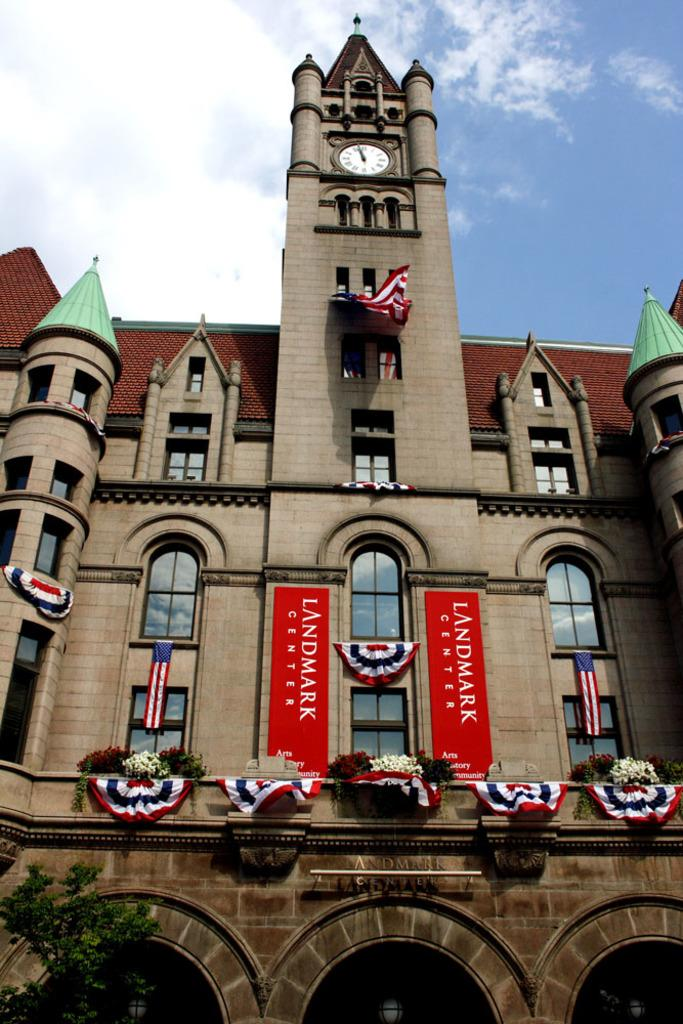What type of structure is the main subject of the image? There is a castle in the image. What decorative elements are present on the castle? Flags are hanging on the castle. What type of natural elements can be seen in the image? There are flowers and a tree in the image. What functional object is present in the image? There is a clock in the image. How would you describe the weather based on the image? The sky is cloudy in the image. What type of canvas is used to create the castle in the image? The image is not a painting or artwork, so there is no canvas used to create the castle. What color of paint is used for the flowers in the image? The image is not a painting or artwork, so there is no paint used for the flowers. 